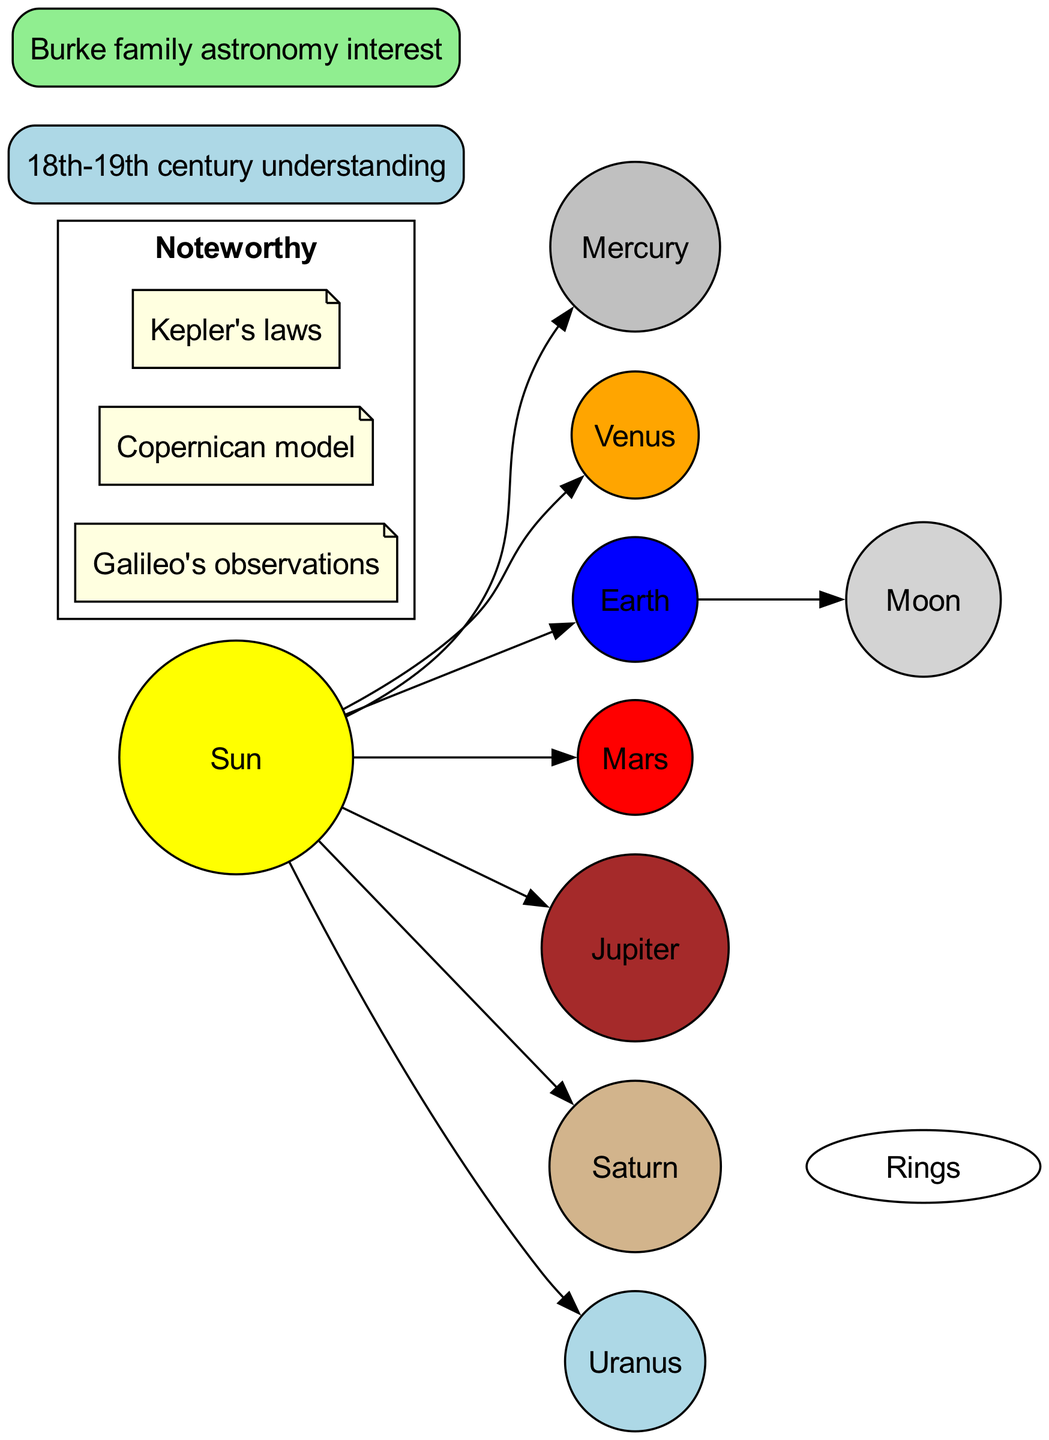What is the center object in the diagram? The diagram indicates that the center object, which all planets orbit around, is the Sun.
Answer: Sun How many planets are represented in the diagram? The diagram lists a total of seven planets orbiting the Sun: Mercury, Venus, Earth, Mars, Jupiter, Saturn, and Uranus, thus the total count is seven.
Answer: 7 Which planet is 3rd from the Sun? The Earth is designated as the 3rd planet in the list provided, directly indicating its position relative to the Sun.
Answer: Earth What notable feature is associated with Saturn in the diagram? The diagram explicitly states that Saturn has visible rings, which is a distinct feature represented.
Answer: Visible rings Which historical model is noted in the diagram? The Copernican model is mentioned as one of the noteworthy elements, reflecting a significant model in astronomy history.
Answer: Copernican model What is the name of Earth's moon as shown in the diagram? The diagram names the moon associated with Earth as the Moon, which is specified in the Earth details section.
Answer: Moon Which planets are shown in orange? In the diagram context, Jupiter is depicted in orange among the listed planets, aligning with its designated color for visual representation.
Answer: Jupiter What does the term "Noteworthy" refer to in the context of this diagram? The term "Noteworthy" denotes a section in the diagram that highlights significant astronomical observations, such as Galileo's observations and Kepler's laws.
Answer: Galileo's observations, Copernican model, Kepler's laws Which planet is the closest to the Sun? According to the arrangement in the diagram, Mercury is shown as the closest planet to the Sun in the solar system representation.
Answer: Mercury In which century was the astronomical understanding, shown in this diagram, established? The historical context referred to in the diagram indicates that the astronomical understanding is rooted in the 18th-19th century, aligning with that time period.
Answer: 18th-19th century 